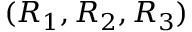<formula> <loc_0><loc_0><loc_500><loc_500>( R _ { 1 } , R _ { 2 } , R _ { 3 } )</formula> 